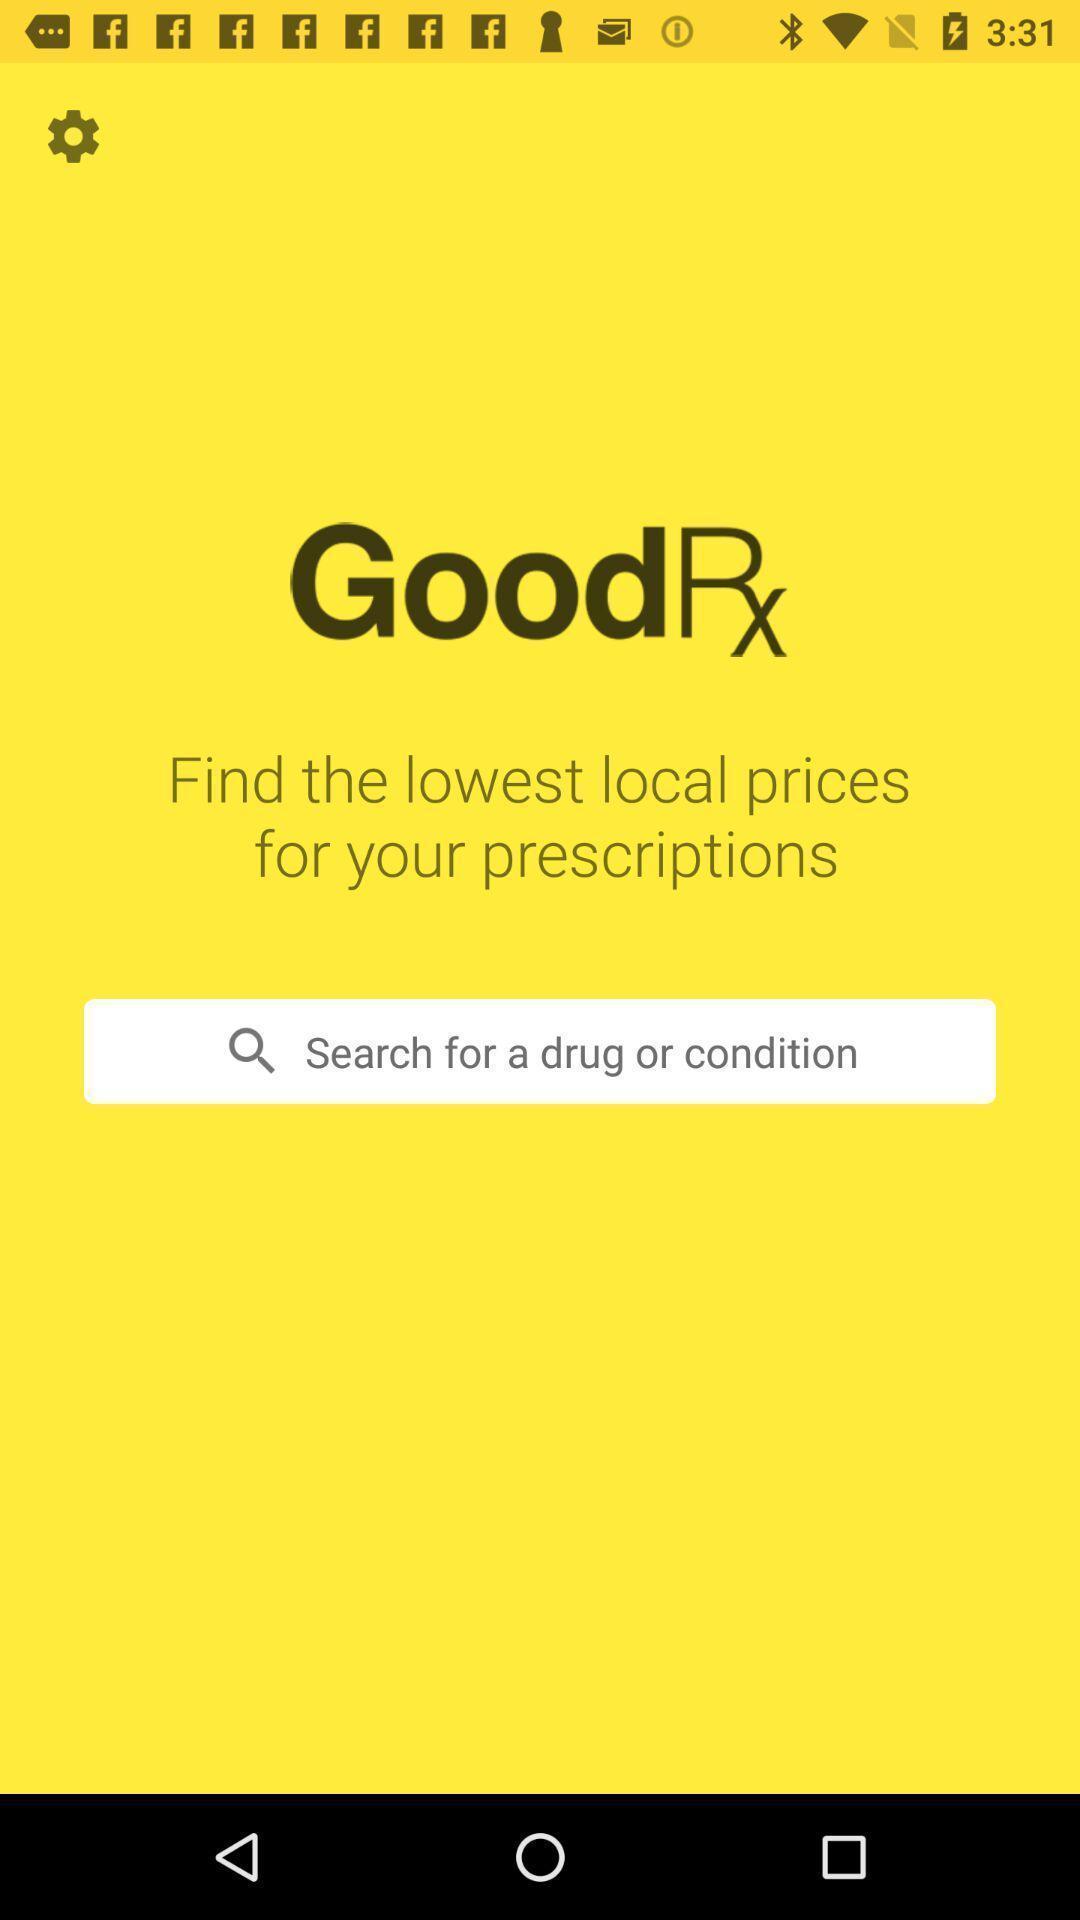What details can you identify in this image? Search box showing in this page. 